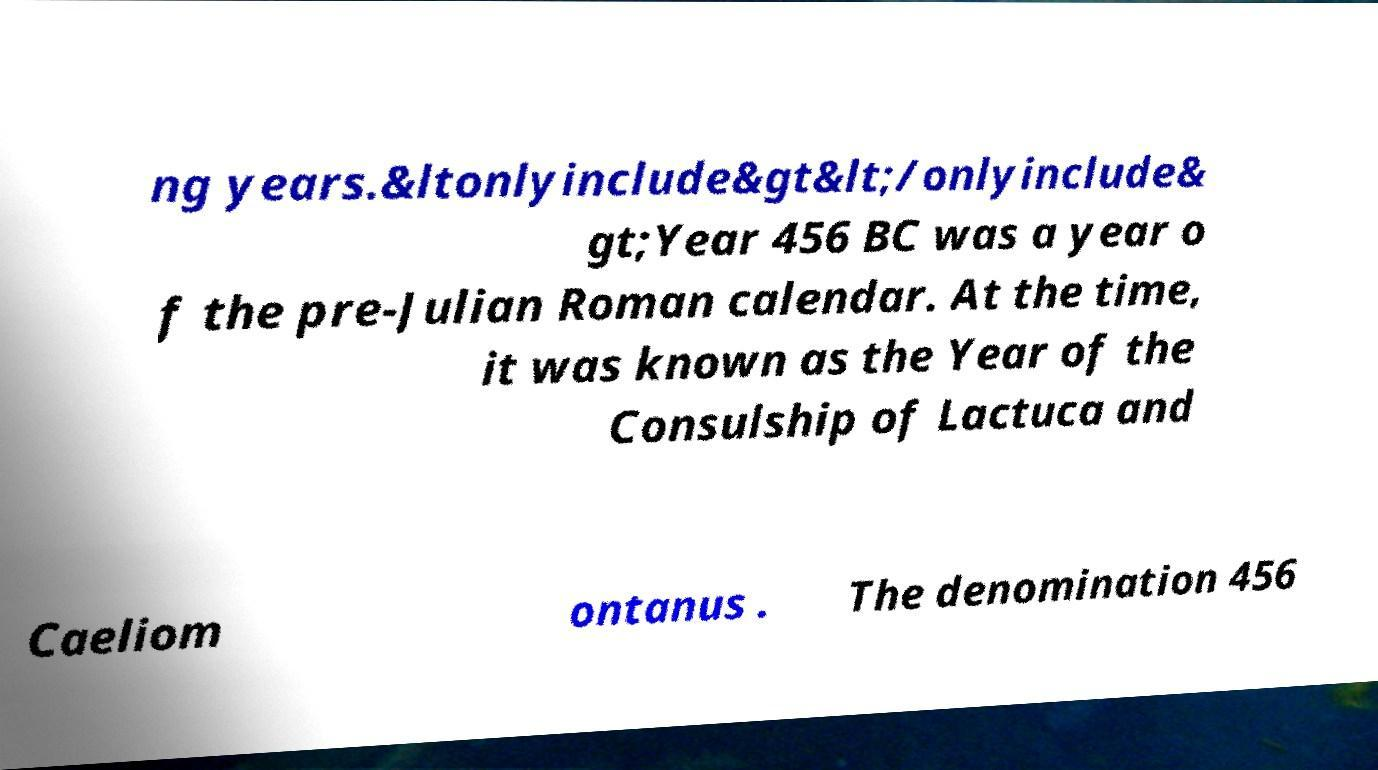I need the written content from this picture converted into text. Can you do that? ng years.&ltonlyinclude&gt&lt;/onlyinclude& gt;Year 456 BC was a year o f the pre-Julian Roman calendar. At the time, it was known as the Year of the Consulship of Lactuca and Caeliom ontanus . The denomination 456 